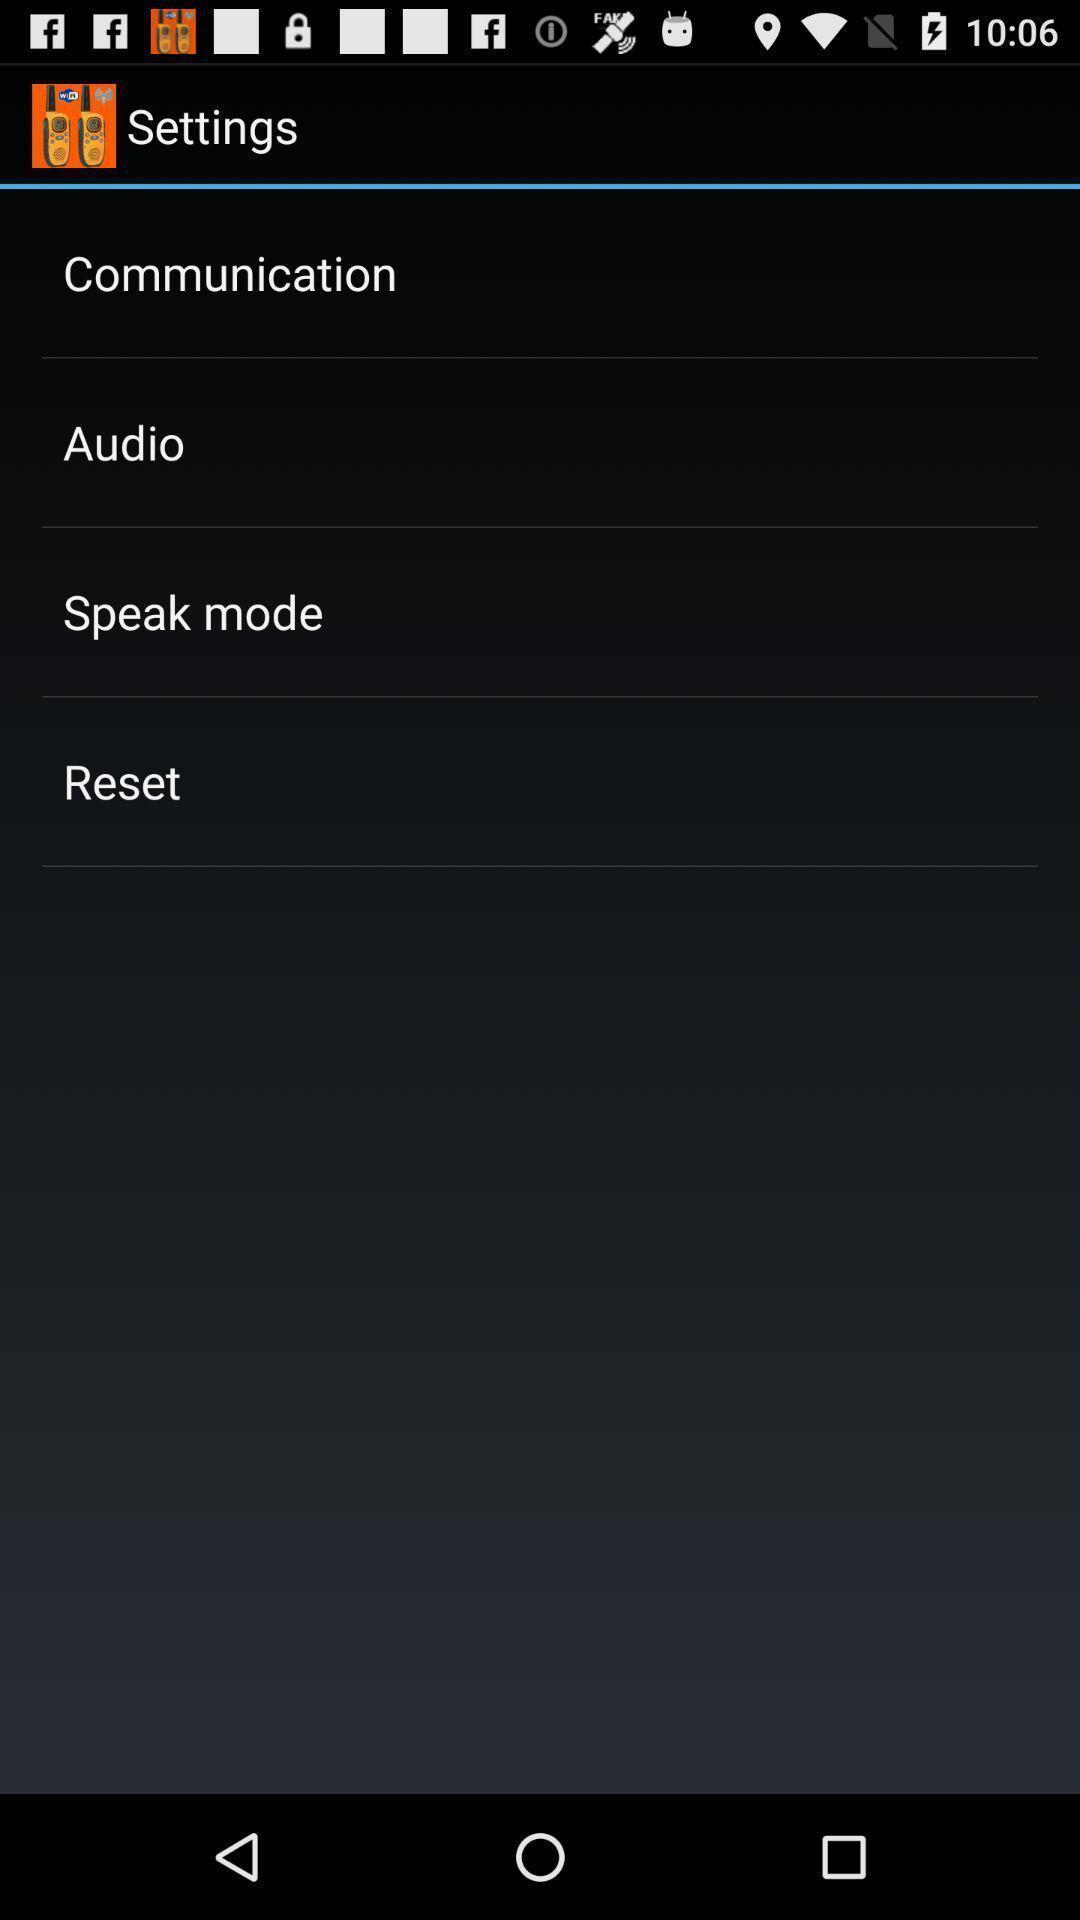Describe this image in words. Settings page. 